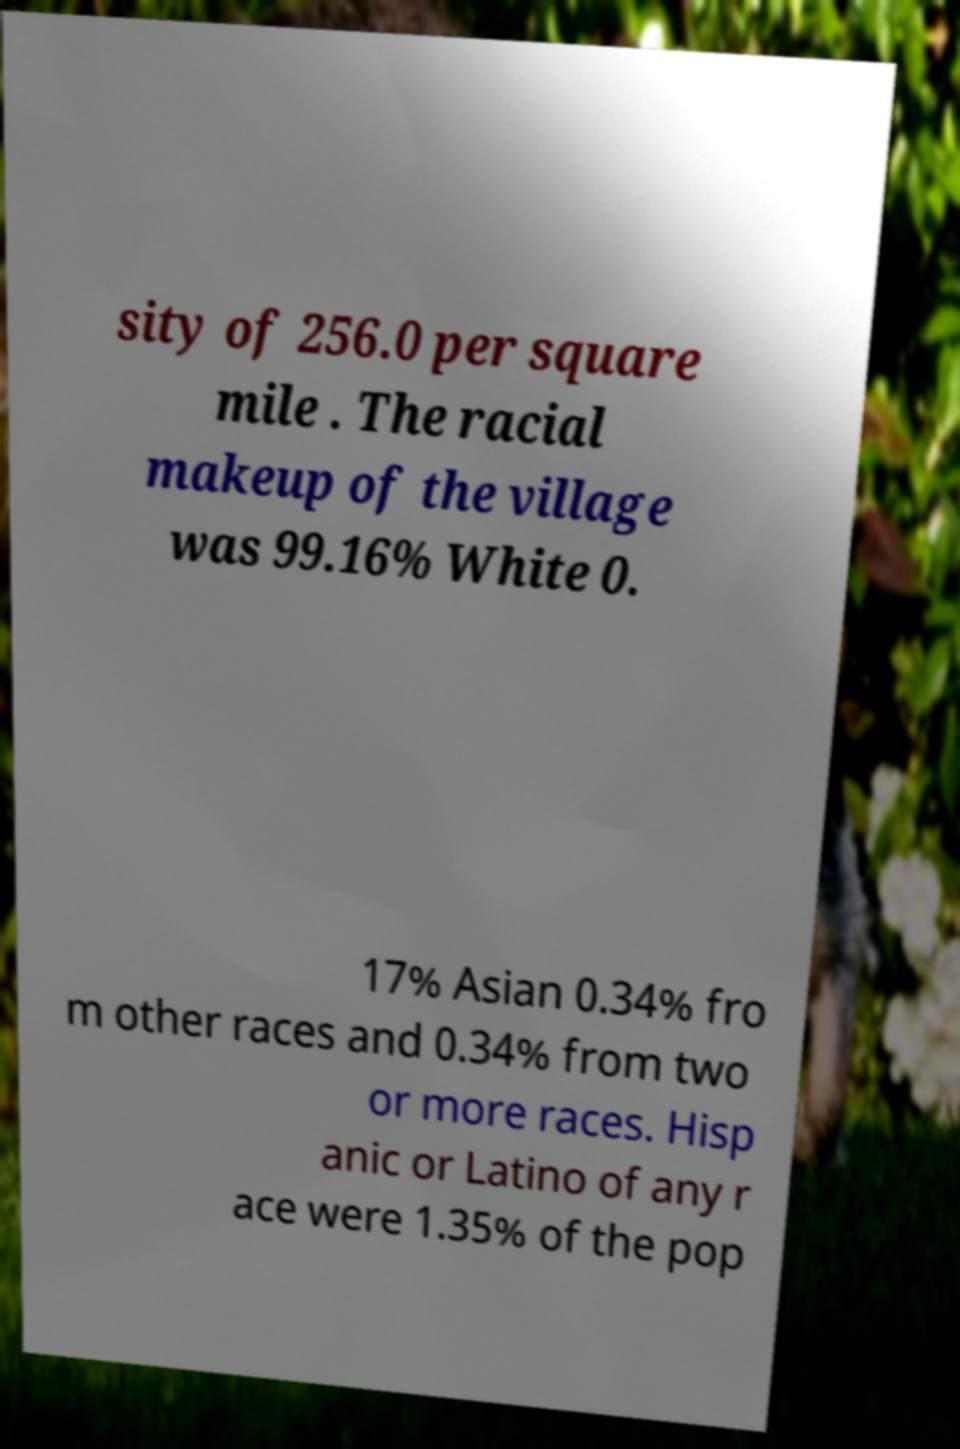Could you extract and type out the text from this image? sity of 256.0 per square mile . The racial makeup of the village was 99.16% White 0. 17% Asian 0.34% fro m other races and 0.34% from two or more races. Hisp anic or Latino of any r ace were 1.35% of the pop 